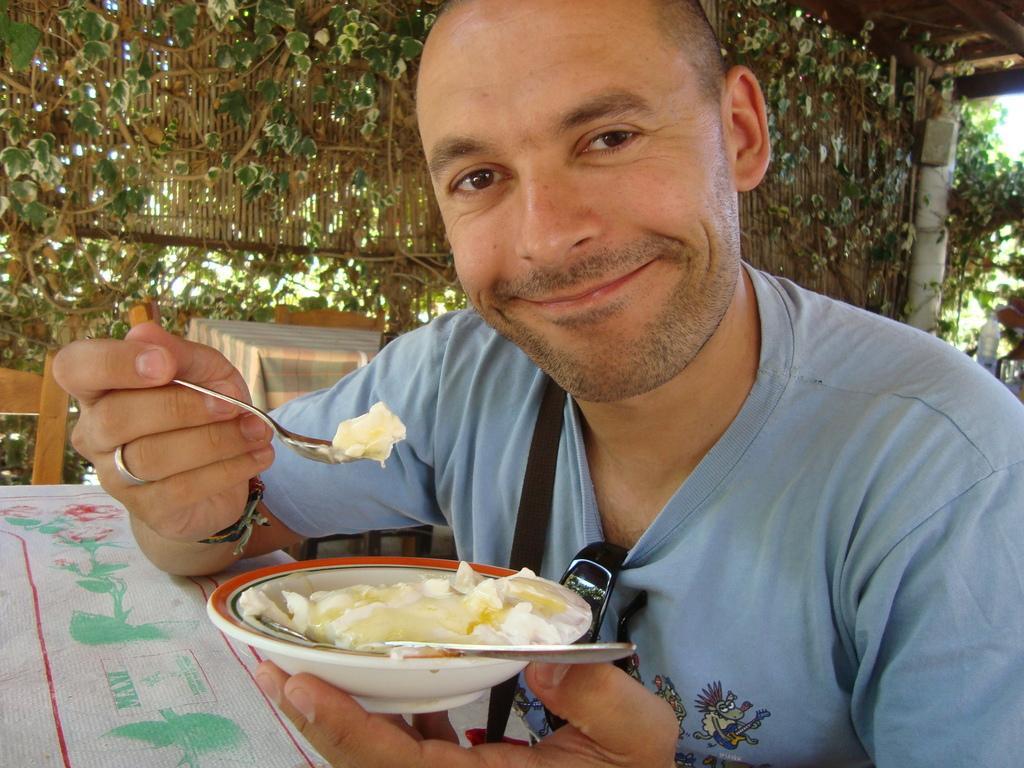Please provide a concise description of this image. In the image there is a man, he is holding a bowl containing some food item with one hand and a spoon with another hand. There is a table in front of him and behind the table there is a chair. In the background there are many plants. 